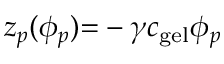<formula> <loc_0><loc_0><loc_500><loc_500>z _ { p } ( \phi _ { p } ) { = } - \gamma c _ { g e l } \phi _ { p }</formula> 